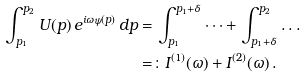<formula> <loc_0><loc_0><loc_500><loc_500>\int _ { p _ { 1 } } ^ { p _ { 2 } } U ( p ) \, e ^ { i \omega \psi ( p ) } \, d p & = \int _ { p _ { 1 } } ^ { p _ { 1 } + \delta } \dots + \int _ { p _ { 1 } + \delta } ^ { p _ { 2 } } \dots \\ & = \colon I ^ { ( 1 ) } ( \omega ) + I ^ { ( 2 ) } ( \omega ) \, .</formula> 